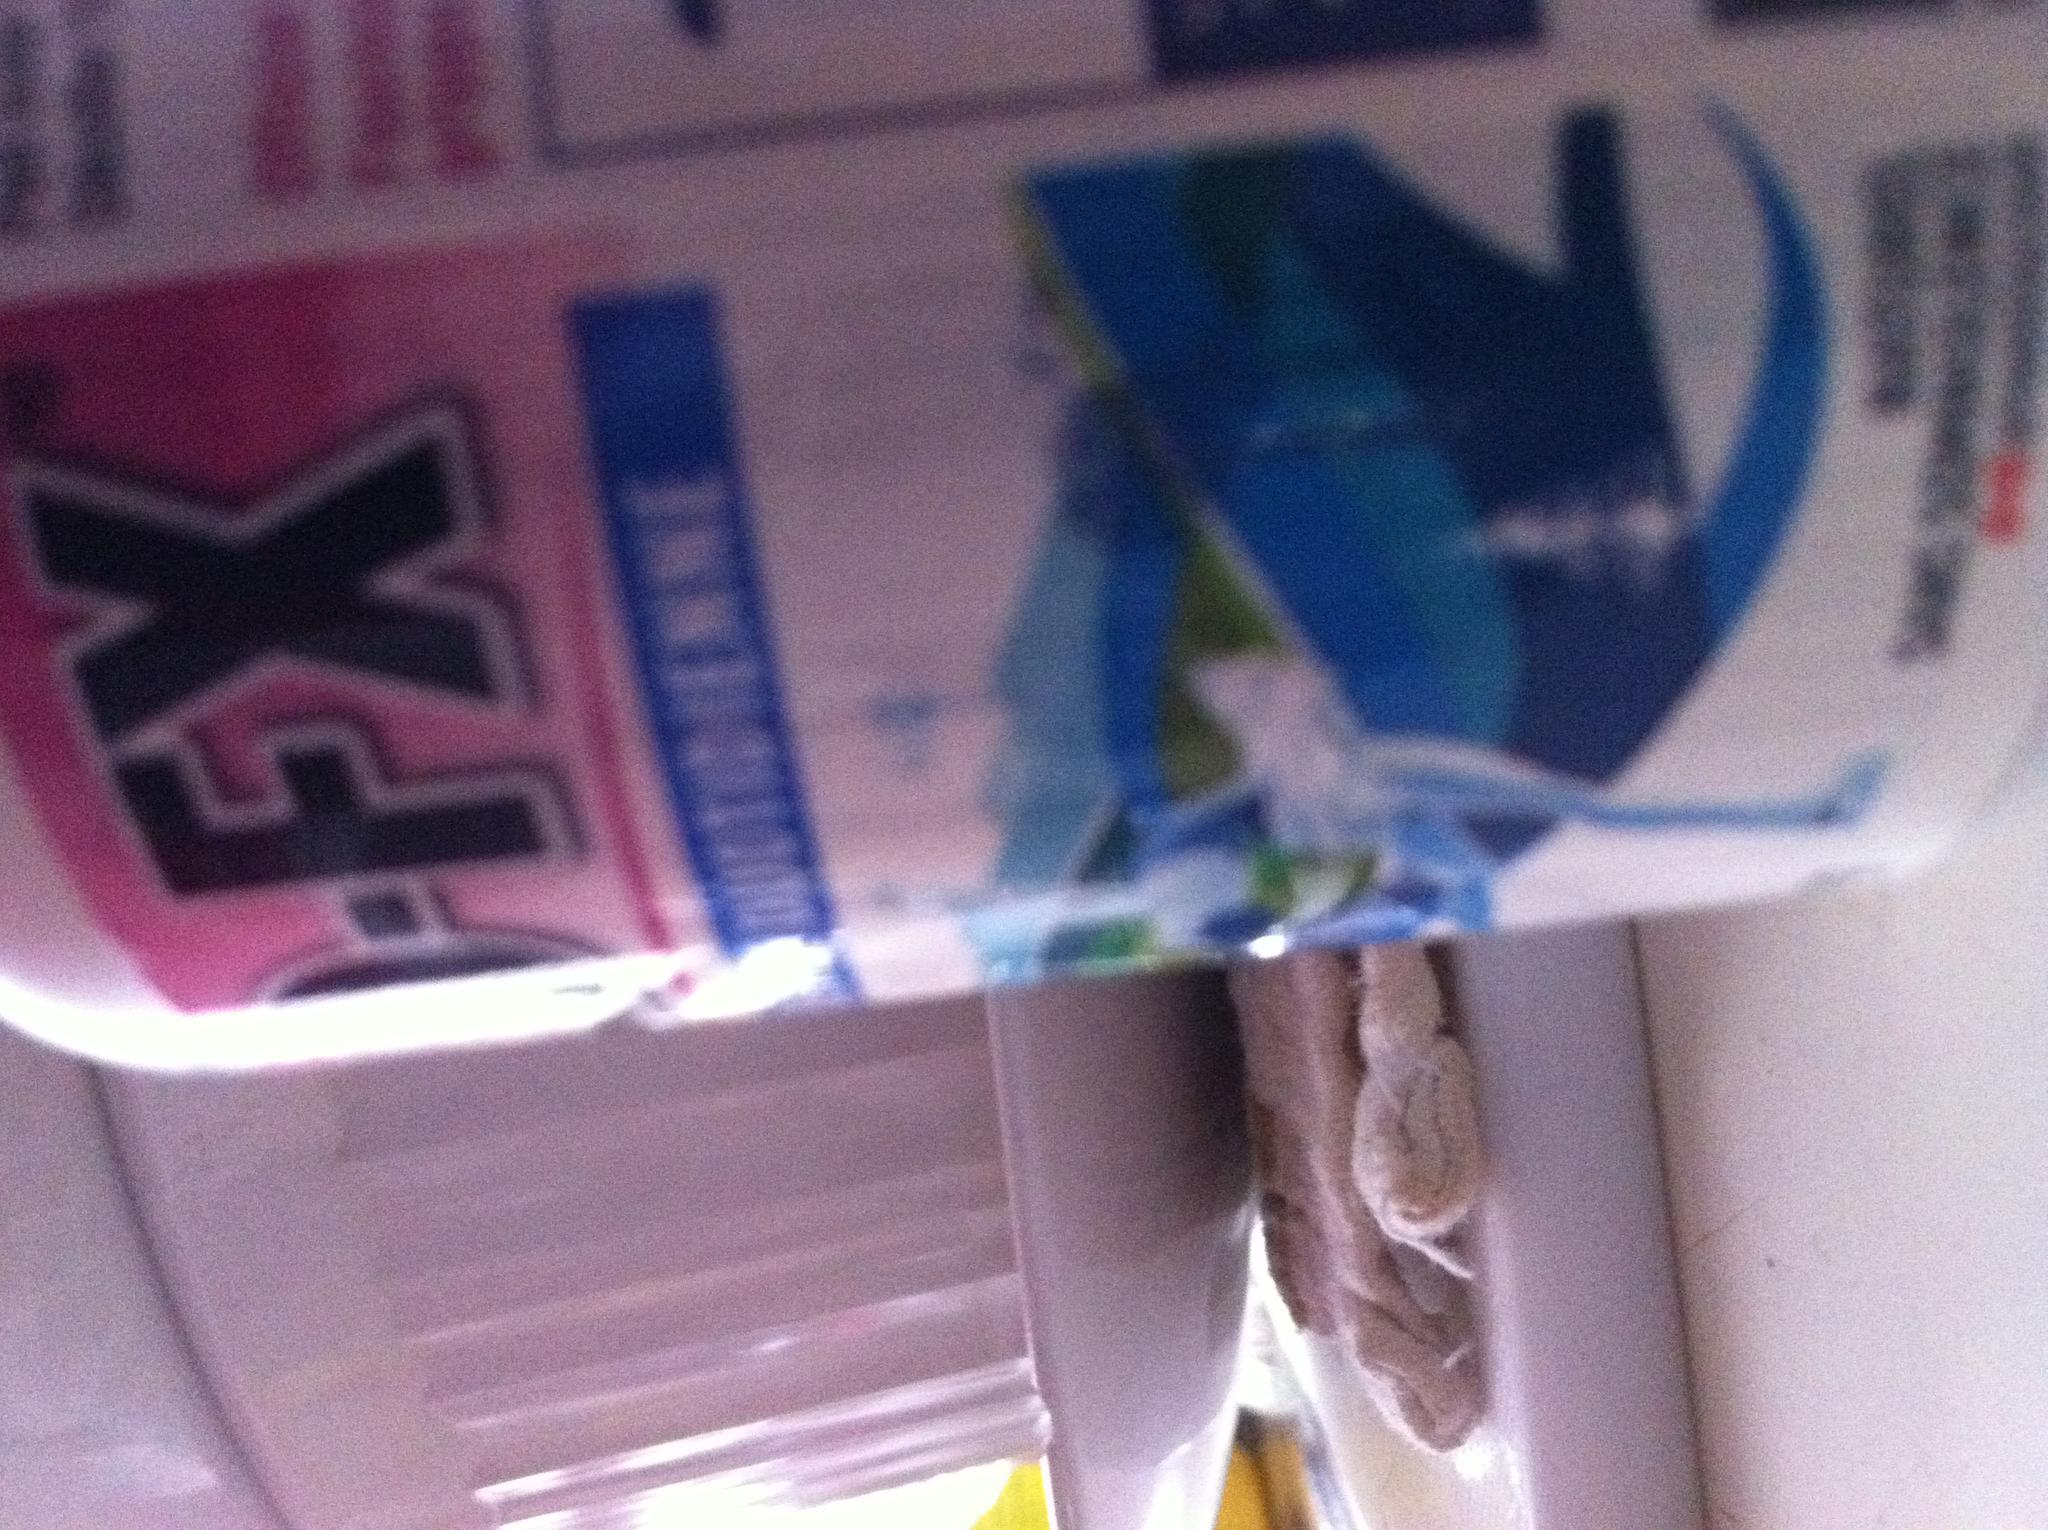What type of pills are these? The photo provided is blurry and lacks clear details necessary to safely identify the medication. For accurate identification, it's important to have a clearer picture showing the text and details on the pill packaging or the pill itself. If you have the medication in question, I recommend consulting a pharmacist or using a reliable medication identification tool online. Always ensure you're handling medications safely and according to prescription guidelines. 